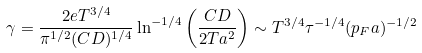<formula> <loc_0><loc_0><loc_500><loc_500>\gamma = \frac { 2 e T ^ { 3 / 4 } } { \pi ^ { 1 / 2 } ( C D ) ^ { 1 / 4 } } \ln ^ { - 1 / 4 } \left ( \frac { C D } { 2 T a ^ { 2 } } \right ) \sim T ^ { 3 / 4 } \tau ^ { - 1 / 4 } ( p _ { F } a ) ^ { - 1 / 2 }</formula> 